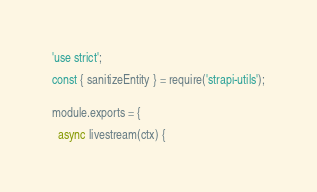<code> <loc_0><loc_0><loc_500><loc_500><_JavaScript_>'use strict';

const { sanitizeEntity } = require('strapi-utils');


module.exports = {

  async livestream(ctx) {</code> 